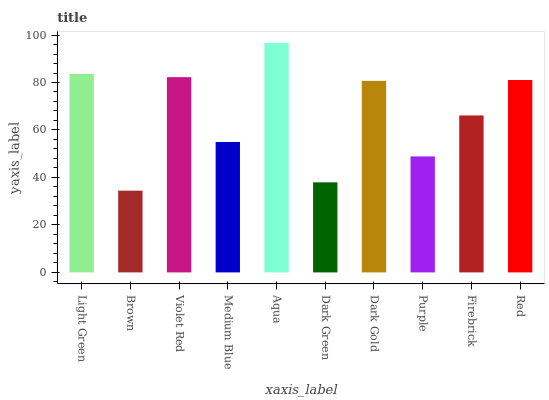Is Brown the minimum?
Answer yes or no. Yes. Is Aqua the maximum?
Answer yes or no. Yes. Is Violet Red the minimum?
Answer yes or no. No. Is Violet Red the maximum?
Answer yes or no. No. Is Violet Red greater than Brown?
Answer yes or no. Yes. Is Brown less than Violet Red?
Answer yes or no. Yes. Is Brown greater than Violet Red?
Answer yes or no. No. Is Violet Red less than Brown?
Answer yes or no. No. Is Dark Gold the high median?
Answer yes or no. Yes. Is Firebrick the low median?
Answer yes or no. Yes. Is Medium Blue the high median?
Answer yes or no. No. Is Aqua the low median?
Answer yes or no. No. 